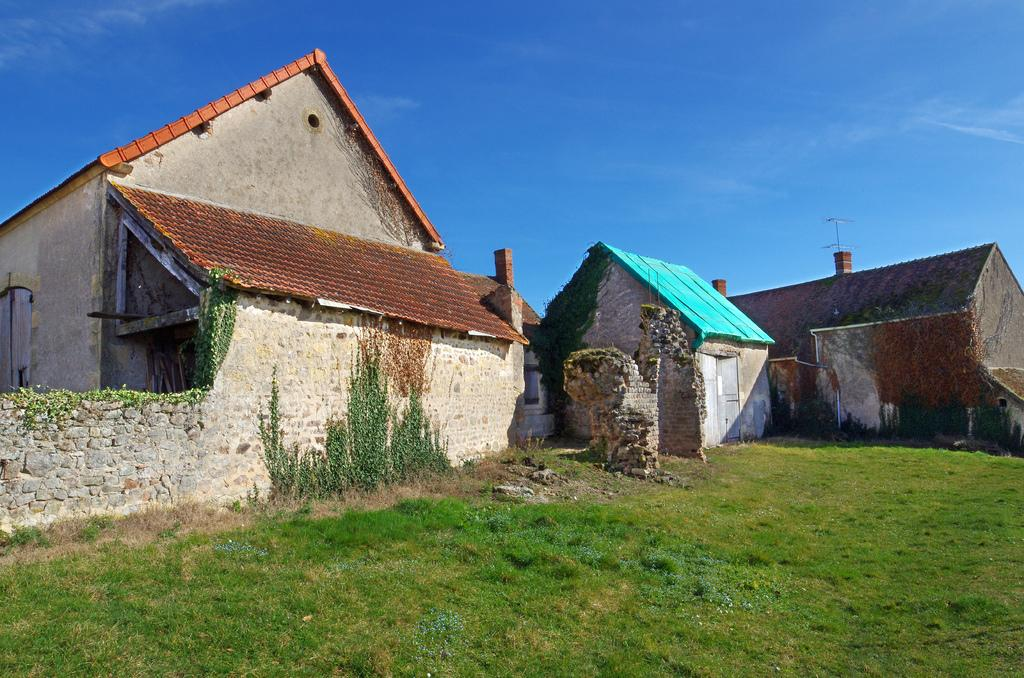What type of structures are located in the center of the image? There are houses in the center of the image. What type of vegetation is at the bottom of the image? There is grass at the bottom of the image. What is visible at the top of the image? The sky is visible at the top of the image. Can you see a horn on any of the houses in the image? There is no horn present on any of the houses in the image. What type of lumber is used to construct the houses in the image? The provided facts do not mention the type of lumber used to construct the houses, so we cannot determine that information from the image. Are any of the residents wearing vests in the image? The provided facts do not mention any residents or clothing, so we cannot determine if anyone is wearing a vest in the image. 